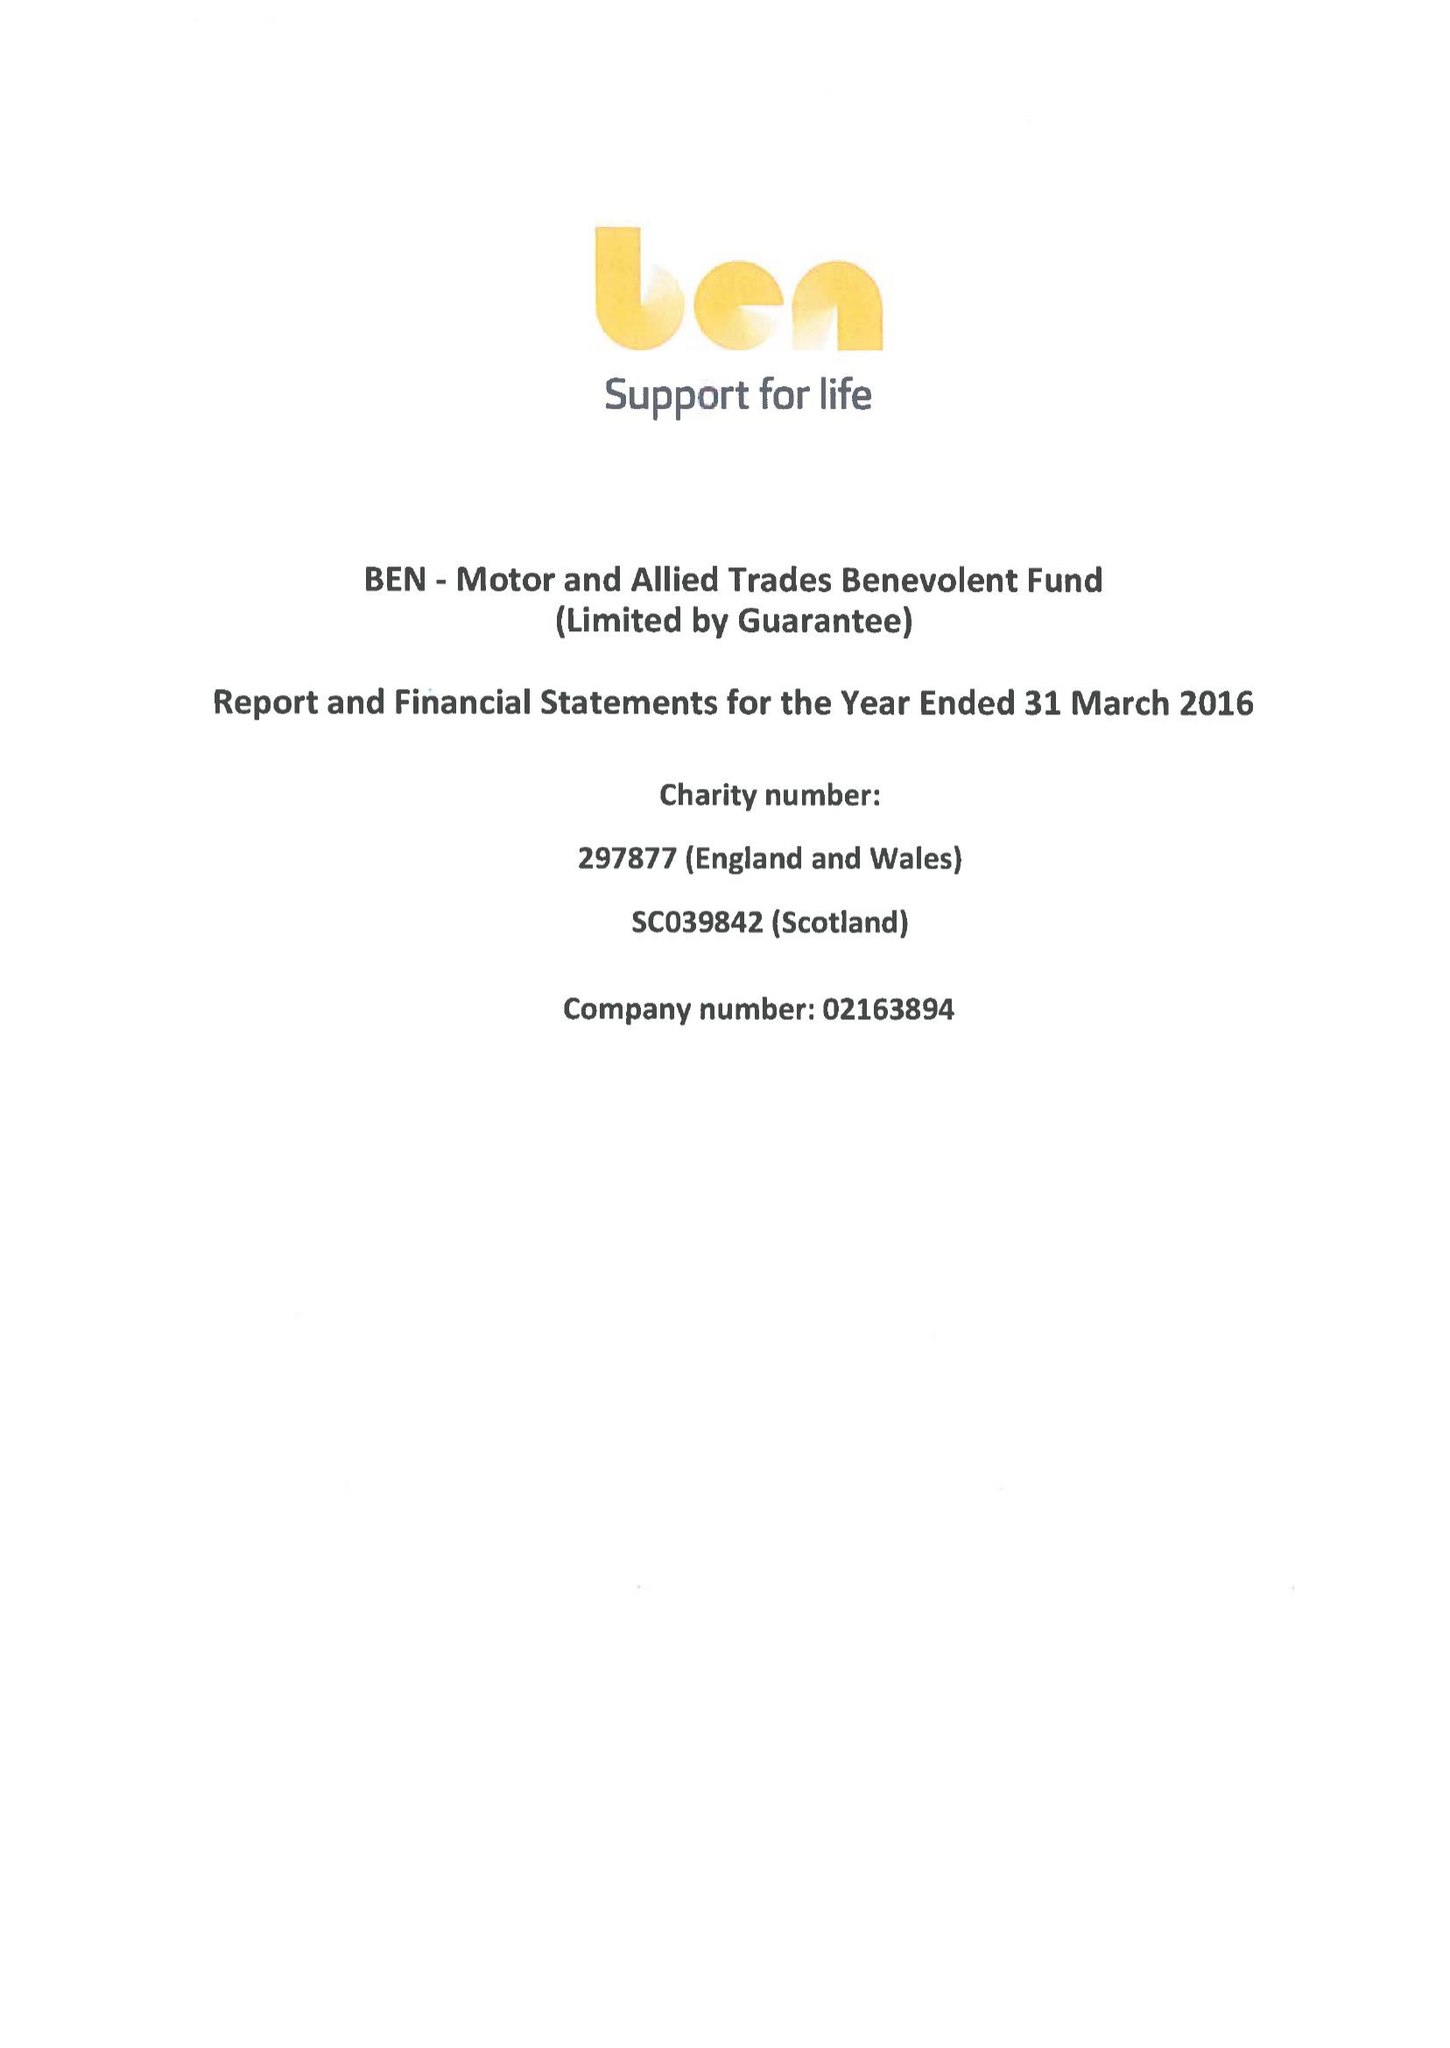What is the value for the charity_name?
Answer the question using a single word or phrase. Ben - Motor and Allied Trades Benevolent Fund 